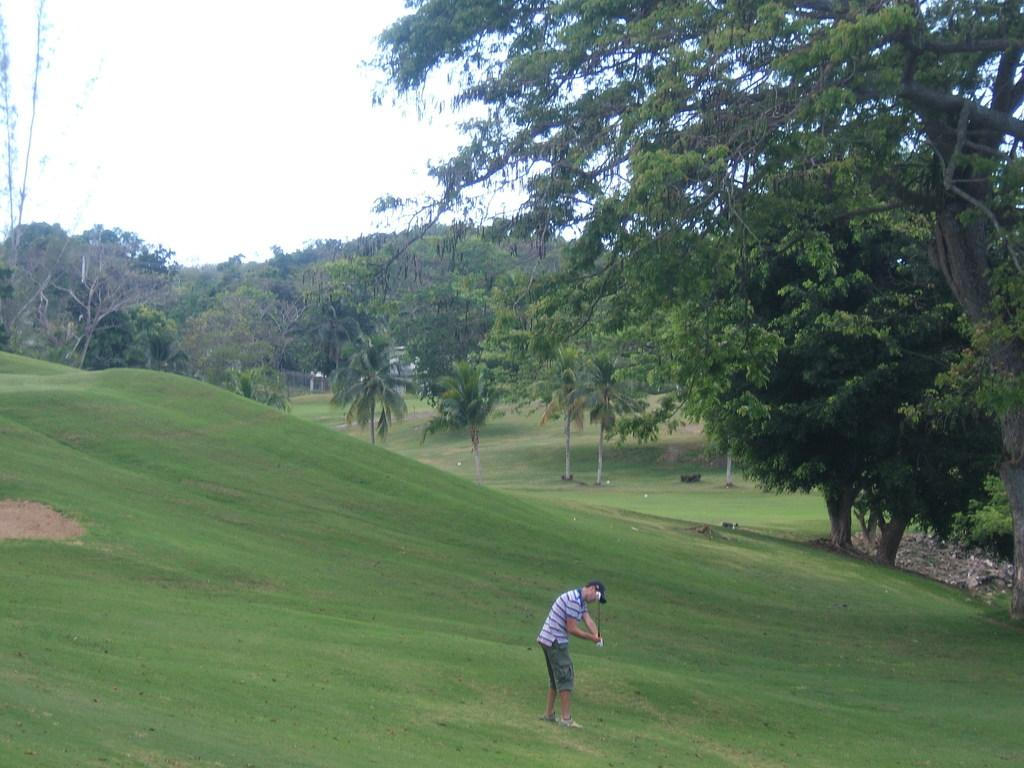What is the main subject of the image? There is a person standing in the image. What type of vegetation can be seen in the image? There are trees with branches and leaves in the image. What is the ground covered with in the image? There is grass visible in the image. What color is the sock on the person's foot in the image? There is no sock visible on the person's foot in the image. What type of canvas is being used to paint the trees in the image? There is no canvas or painting activity present in the image; it is a photograph of a person standing among trees and grass. 